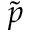Convert formula to latex. <formula><loc_0><loc_0><loc_500><loc_500>\tilde { p }</formula> 